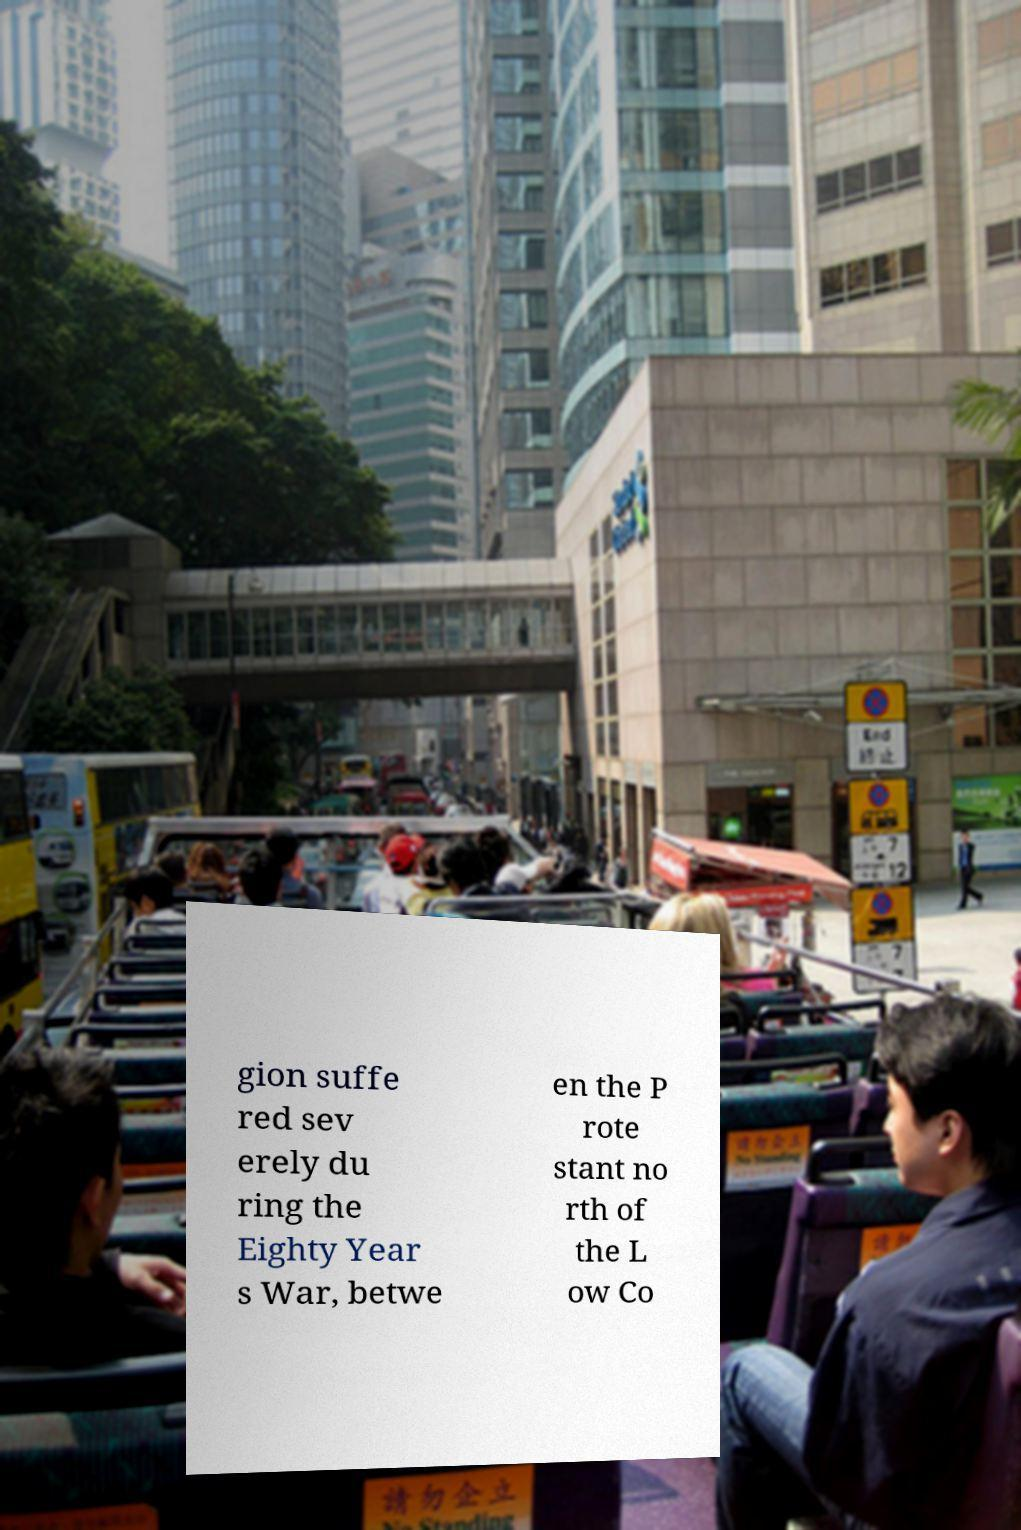Please read and relay the text visible in this image. What does it say? gion suffe red sev erely du ring the Eighty Year s War, betwe en the P rote stant no rth of the L ow Co 